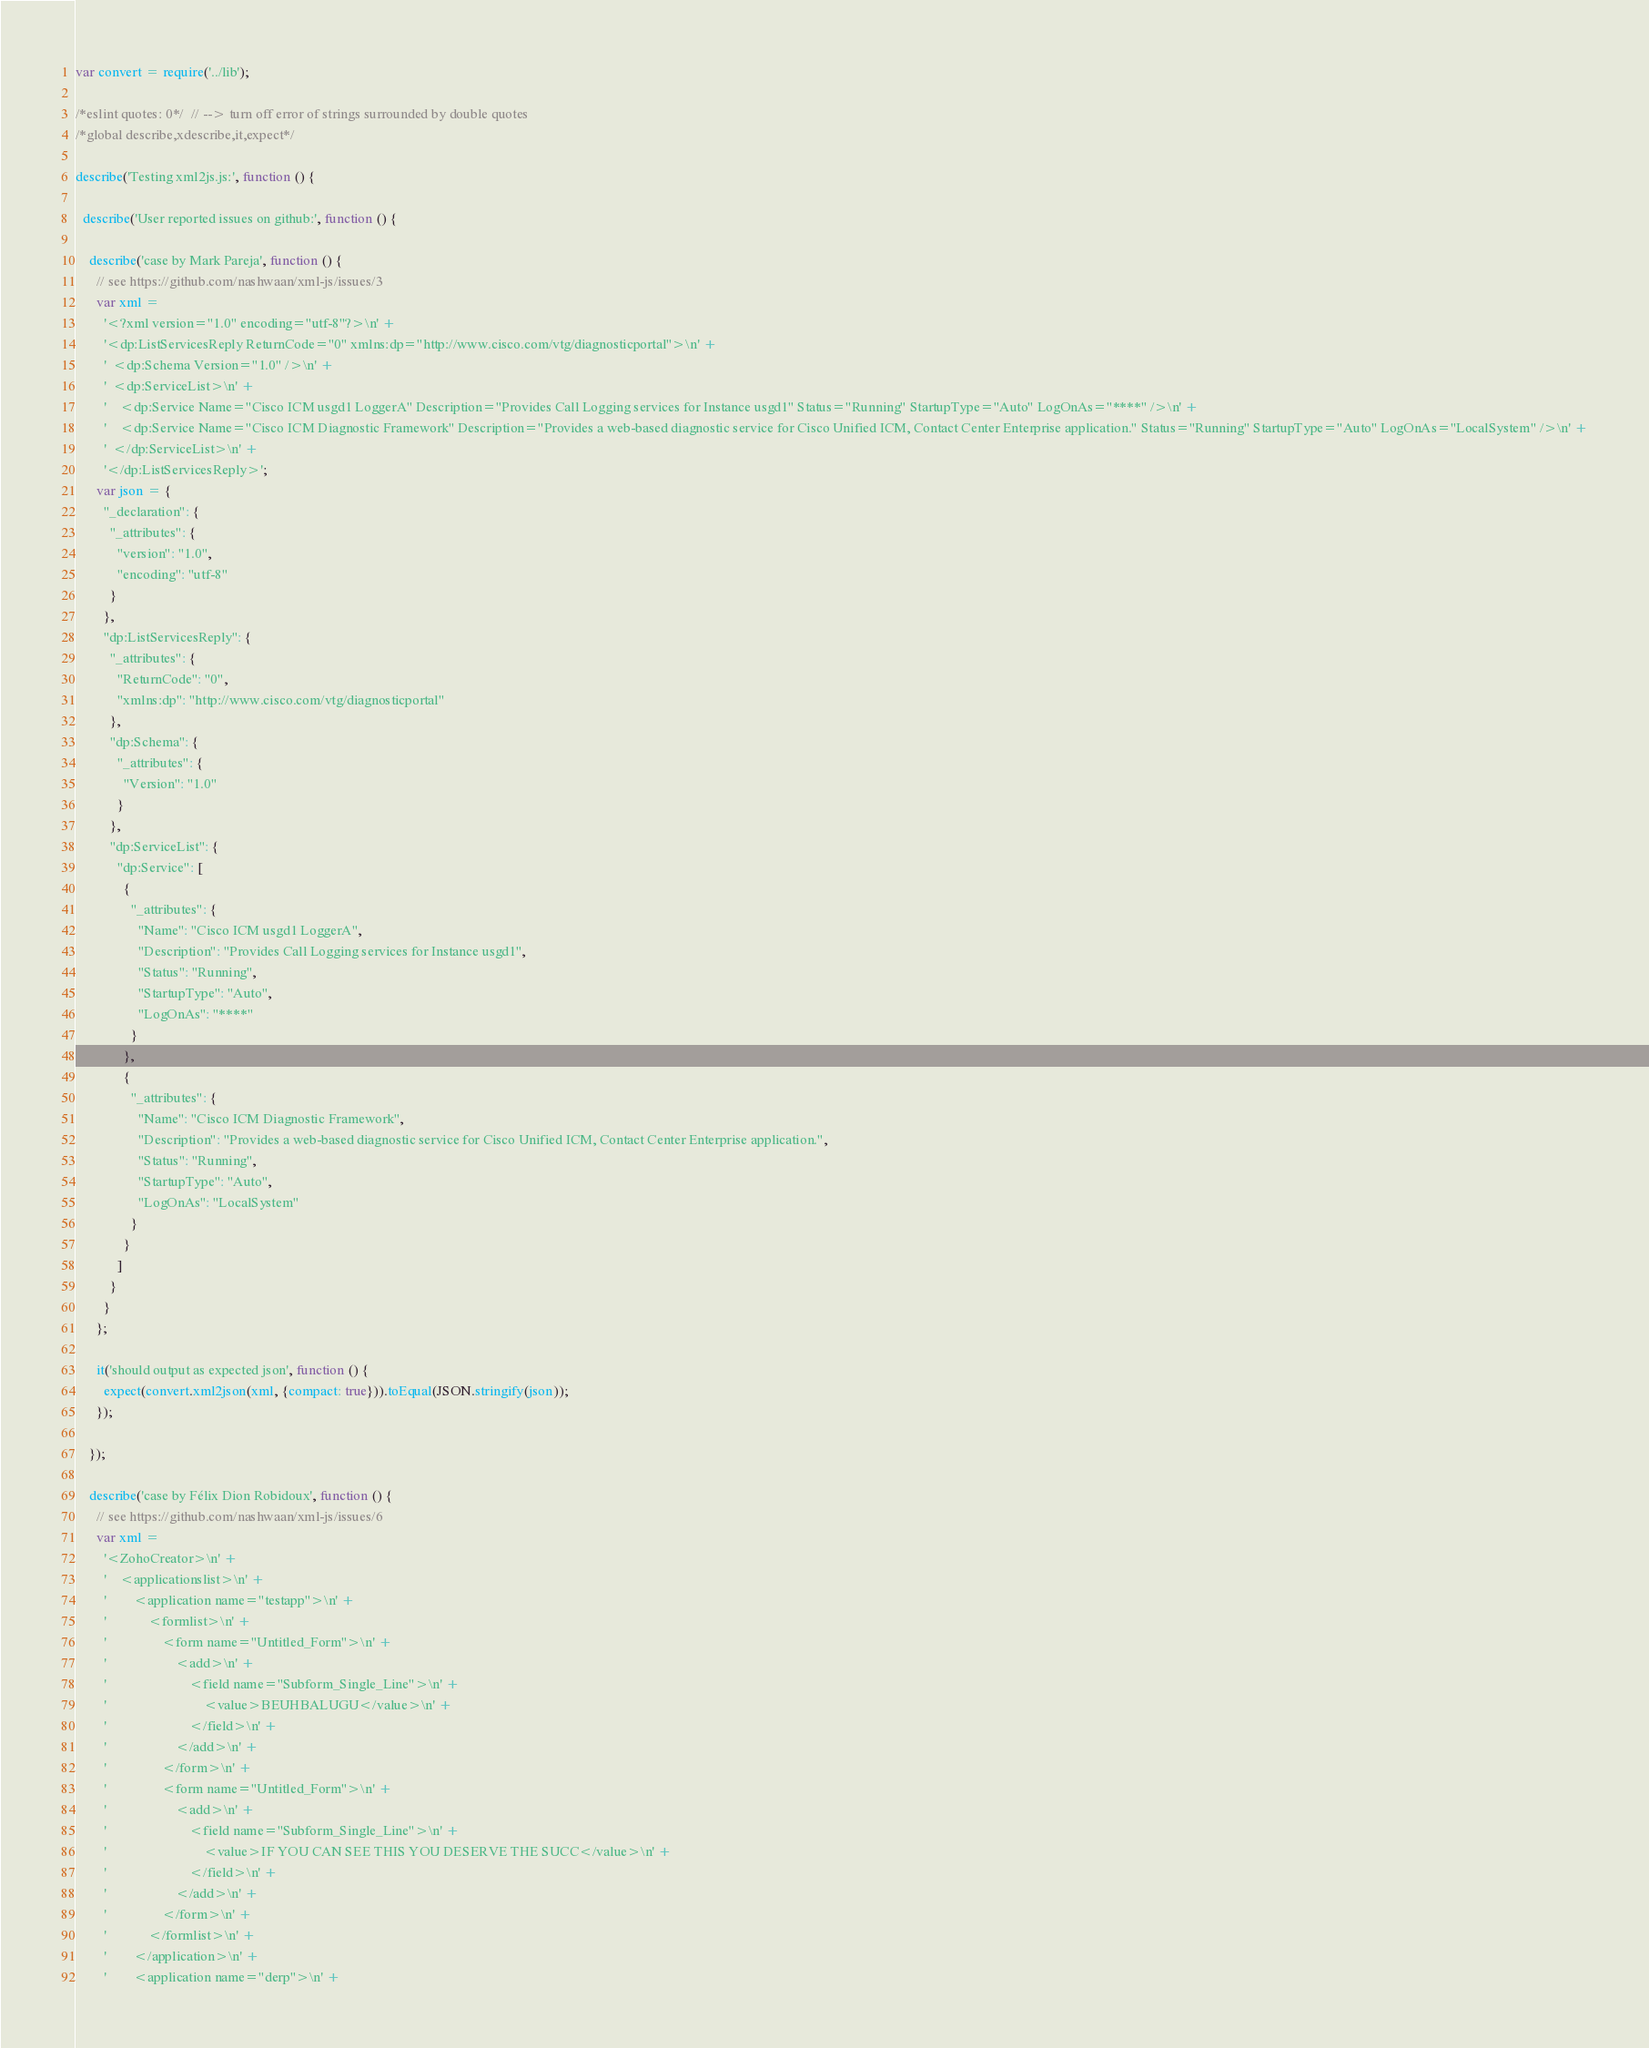<code> <loc_0><loc_0><loc_500><loc_500><_JavaScript_>var convert = require('../lib');

/*eslint quotes: 0*/  // --> turn off error of strings surrounded by double quotes
/*global describe,xdescribe,it,expect*/

describe('Testing xml2js.js:', function () {

  describe('User reported issues on github:', function () {

    describe('case by Mark Pareja', function () {
      // see https://github.com/nashwaan/xml-js/issues/3
      var xml =
        '<?xml version="1.0" encoding="utf-8"?>\n' +
        '<dp:ListServicesReply ReturnCode="0" xmlns:dp="http://www.cisco.com/vtg/diagnosticportal">\n' +
        '  <dp:Schema Version="1.0" />\n' +
        '  <dp:ServiceList>\n' +
        '    <dp:Service Name="Cisco ICM usgd1 LoggerA" Description="Provides Call Logging services for Instance usgd1" Status="Running" StartupType="Auto" LogOnAs="****" />\n' +
        '    <dp:Service Name="Cisco ICM Diagnostic Framework" Description="Provides a web-based diagnostic service for Cisco Unified ICM, Contact Center Enterprise application." Status="Running" StartupType="Auto" LogOnAs="LocalSystem" />\n' +
        '  </dp:ServiceList>\n' +
        '</dp:ListServicesReply>';
      var json = {
        "_declaration": {
          "_attributes": {
            "version": "1.0",
            "encoding": "utf-8"
          }
        },
        "dp:ListServicesReply": {
          "_attributes": {
            "ReturnCode": "0",
            "xmlns:dp": "http://www.cisco.com/vtg/diagnosticportal"
          },
          "dp:Schema": {
            "_attributes": {
              "Version": "1.0"
            }
          },
          "dp:ServiceList": {
            "dp:Service": [
              {
                "_attributes": {
                  "Name": "Cisco ICM usgd1 LoggerA",
                  "Description": "Provides Call Logging services for Instance usgd1",
                  "Status": "Running",
                  "StartupType": "Auto",
                  "LogOnAs": "****"
                }
              },
              {
                "_attributes": {
                  "Name": "Cisco ICM Diagnostic Framework",
                  "Description": "Provides a web-based diagnostic service for Cisco Unified ICM, Contact Center Enterprise application.",
                  "Status": "Running",
                  "StartupType": "Auto",
                  "LogOnAs": "LocalSystem"
                }
              }
            ]
          }
        }
      };

      it('should output as expected json', function () {
        expect(convert.xml2json(xml, {compact: true})).toEqual(JSON.stringify(json));
      });

    });

    describe('case by Félix Dion Robidoux', function () {
      // see https://github.com/nashwaan/xml-js/issues/6
      var xml =
        '<ZohoCreator>\n' +
        '    <applicationslist>\n' +
        '        <application name="testapp">\n' +
        '            <formlist>\n' +
        '                <form name="Untitled_Form">\n' +
        '                    <add>\n' +
        '                        <field name="Subform_Single_Line">\n' +
        '                            <value>BEUHBALUGU</value>\n' +
        '                        </field>\n' +
        '                    </add>\n' +
        '                </form>\n' +
        '                <form name="Untitled_Form">\n' +
        '                    <add>\n' +
        '                        <field name="Subform_Single_Line">\n' +
        '                            <value>IF YOU CAN SEE THIS YOU DESERVE THE SUCC</value>\n' +
        '                        </field>\n' +
        '                    </add>\n' +
        '                </form>\n' +
        '            </formlist>\n' +
        '        </application>\n' +
        '        <application name="derp">\n' +</code> 